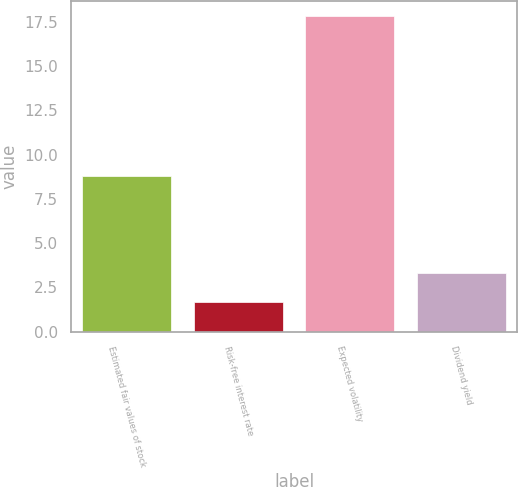Convert chart to OTSL. <chart><loc_0><loc_0><loc_500><loc_500><bar_chart><fcel>Estimated fair values of stock<fcel>Risk-free interest rate<fcel>Expected volatility<fcel>Dividend yield<nl><fcel>8.8<fcel>1.7<fcel>17.8<fcel>3.31<nl></chart> 